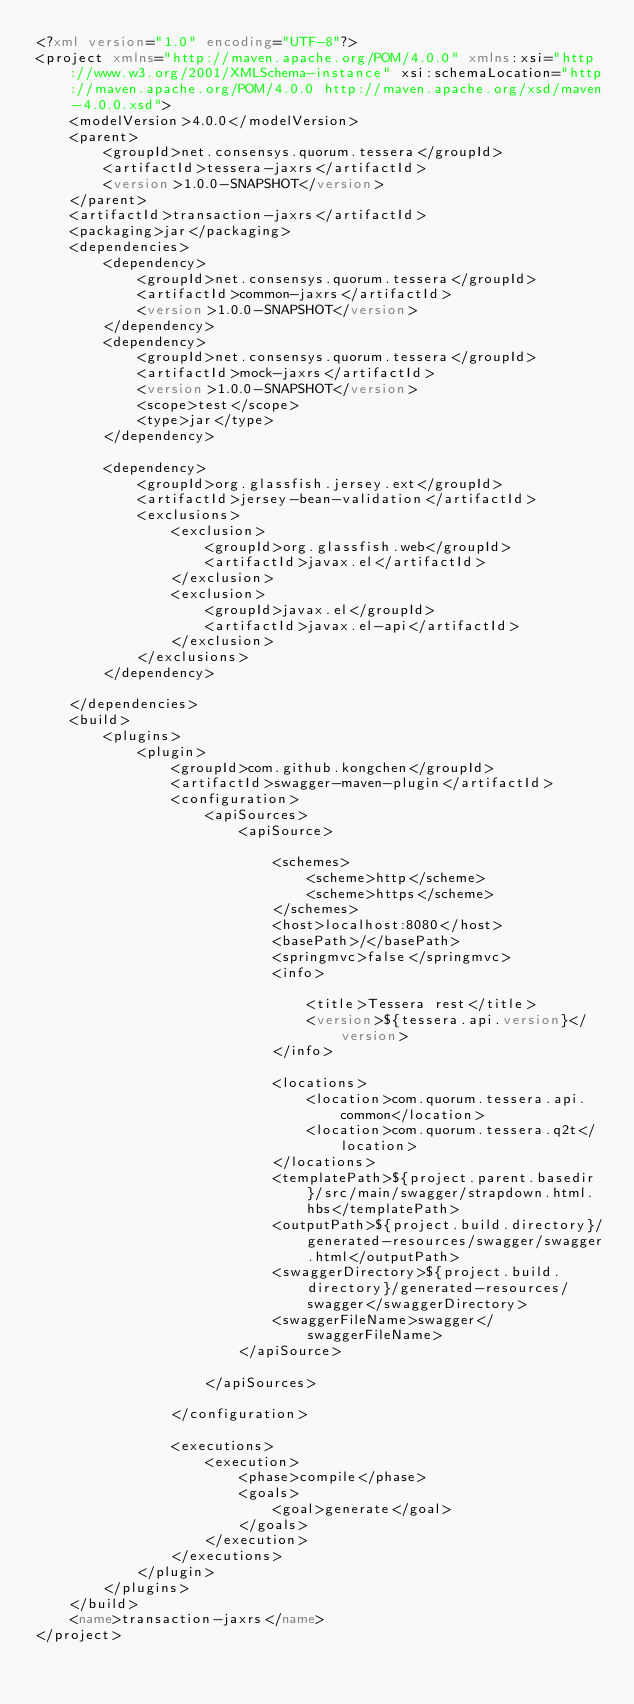Convert code to text. <code><loc_0><loc_0><loc_500><loc_500><_XML_><?xml version="1.0" encoding="UTF-8"?>
<project xmlns="http://maven.apache.org/POM/4.0.0" xmlns:xsi="http://www.w3.org/2001/XMLSchema-instance" xsi:schemaLocation="http://maven.apache.org/POM/4.0.0 http://maven.apache.org/xsd/maven-4.0.0.xsd">
    <modelVersion>4.0.0</modelVersion>
    <parent>
        <groupId>net.consensys.quorum.tessera</groupId>
        <artifactId>tessera-jaxrs</artifactId>
        <version>1.0.0-SNAPSHOT</version>
    </parent>
    <artifactId>transaction-jaxrs</artifactId>
    <packaging>jar</packaging>
    <dependencies>
        <dependency>
            <groupId>net.consensys.quorum.tessera</groupId>
            <artifactId>common-jaxrs</artifactId>
            <version>1.0.0-SNAPSHOT</version>
        </dependency>
        <dependency>
            <groupId>net.consensys.quorum.tessera</groupId>
            <artifactId>mock-jaxrs</artifactId>
            <version>1.0.0-SNAPSHOT</version>
            <scope>test</scope>
            <type>jar</type>
        </dependency>

        <dependency>
            <groupId>org.glassfish.jersey.ext</groupId>
            <artifactId>jersey-bean-validation</artifactId>
            <exclusions>
                <exclusion>
                    <groupId>org.glassfish.web</groupId>
                    <artifactId>javax.el</artifactId>
                </exclusion>
                <exclusion>
                    <groupId>javax.el</groupId>
                    <artifactId>javax.el-api</artifactId>
                </exclusion>
            </exclusions>
        </dependency>

    </dependencies>
    <build>
        <plugins>
            <plugin>
                <groupId>com.github.kongchen</groupId>
                <artifactId>swagger-maven-plugin</artifactId>
                <configuration>
                    <apiSources>
                        <apiSource>

                            <schemes>
                                <scheme>http</scheme>
                                <scheme>https</scheme>
                            </schemes>
                            <host>localhost:8080</host>
                            <basePath>/</basePath>
                            <springmvc>false</springmvc>
                            <info>

                                <title>Tessera rest</title>
                                <version>${tessera.api.version}</version>
                            </info>

                            <locations>
                                <location>com.quorum.tessera.api.common</location>
                                <location>com.quorum.tessera.q2t</location>
                            </locations>
                            <templatePath>${project.parent.basedir}/src/main/swagger/strapdown.html.hbs</templatePath>
                            <outputPath>${project.build.directory}/generated-resources/swagger/swagger.html</outputPath>
                            <swaggerDirectory>${project.build.directory}/generated-resources/swagger</swaggerDirectory>
                            <swaggerFileName>swagger</swaggerFileName>
                        </apiSource>

                    </apiSources>

                </configuration>

                <executions>
                    <execution>
                        <phase>compile</phase>
                        <goals>
                            <goal>generate</goal>
                        </goals>
                    </execution>
                </executions>
            </plugin>
        </plugins>
    </build>
    <name>transaction-jaxrs</name>
</project>
</code> 